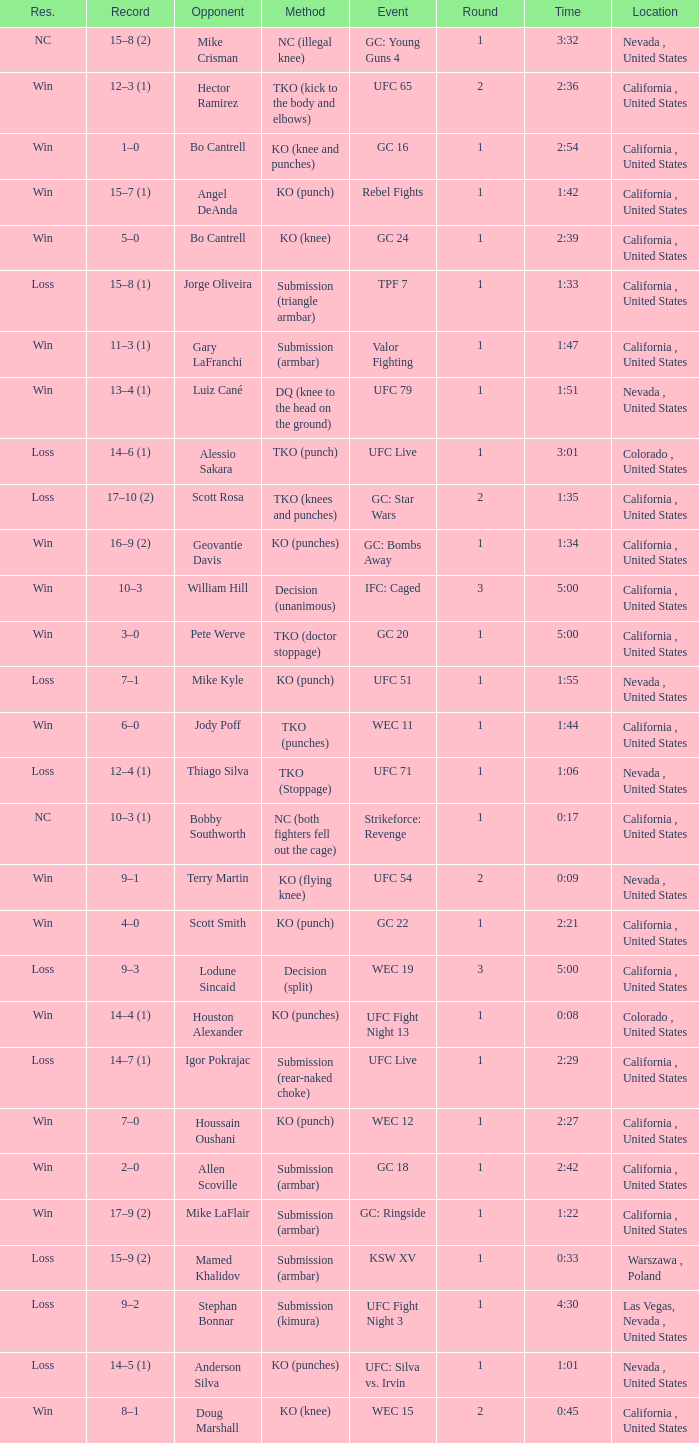What is the method where there is a loss with time 5:00? Decision (split). 